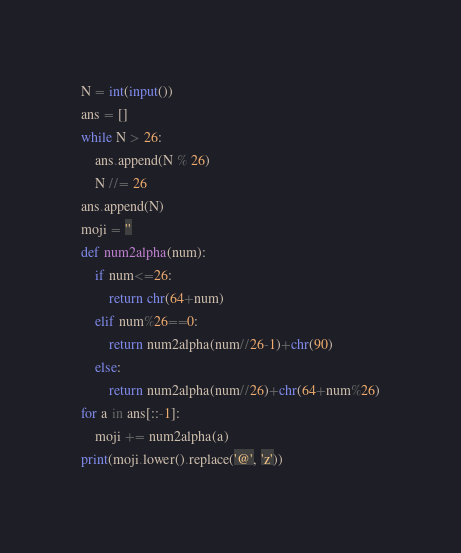<code> <loc_0><loc_0><loc_500><loc_500><_Python_>N = int(input())
ans = []
while N > 26:
    ans.append(N % 26)
    N //= 26
ans.append(N)
moji = ''
def num2alpha(num):
    if num<=26:
        return chr(64+num)
    elif num%26==0:
        return num2alpha(num//26-1)+chr(90)
    else:
        return num2alpha(num//26)+chr(64+num%26)
for a in ans[::-1]:
    moji += num2alpha(a)
print(moji.lower().replace('@', 'z'))</code> 